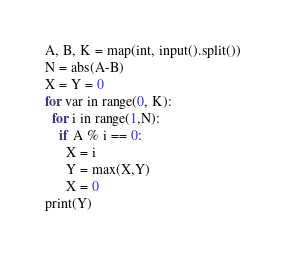Convert code to text. <code><loc_0><loc_0><loc_500><loc_500><_Python_>A, B, K = map(int, input().split())
N = abs(A-B)
X = Y = 0
for var in range(0, K):
  for i in range(1,N):
    if A % i == 0:
      X = i
      Y = max(X,Y)
      X = 0
print(Y)</code> 